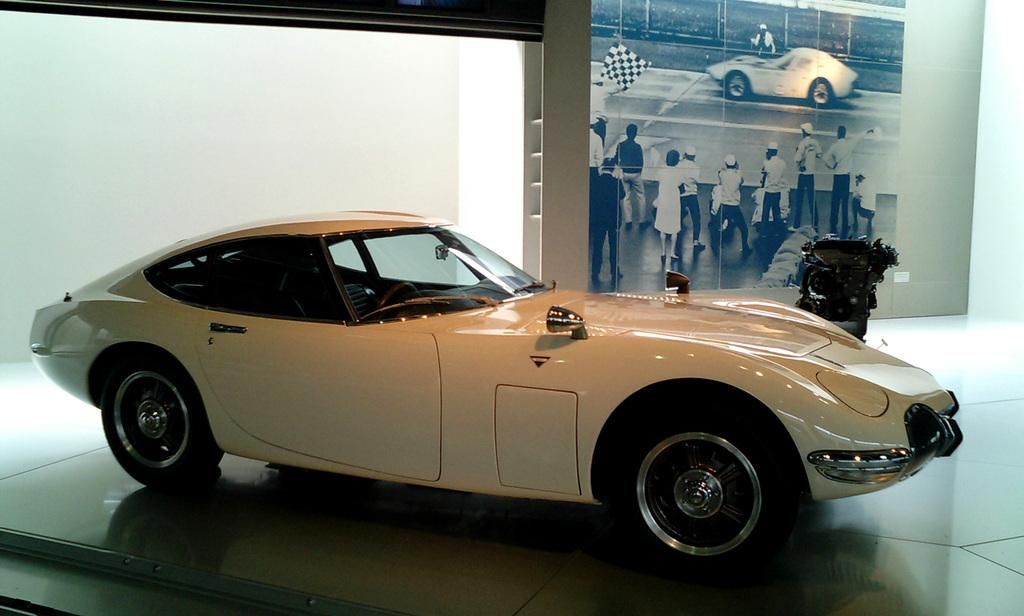What type of vehicle is on the floor in the image? There is a white car on the floor in the image. What is happening on the board in the image? There are people on the board, and there is a vehicle on the board. Can you describe the person holding a flag? One person is holding a flag in the image. How is the board positioned in the image? The board is attached to a white wall in the image. What type of prison can be seen in the image? There is no prison present in the image. How many bikes are visible in the image? There are no bikes present in the image. 